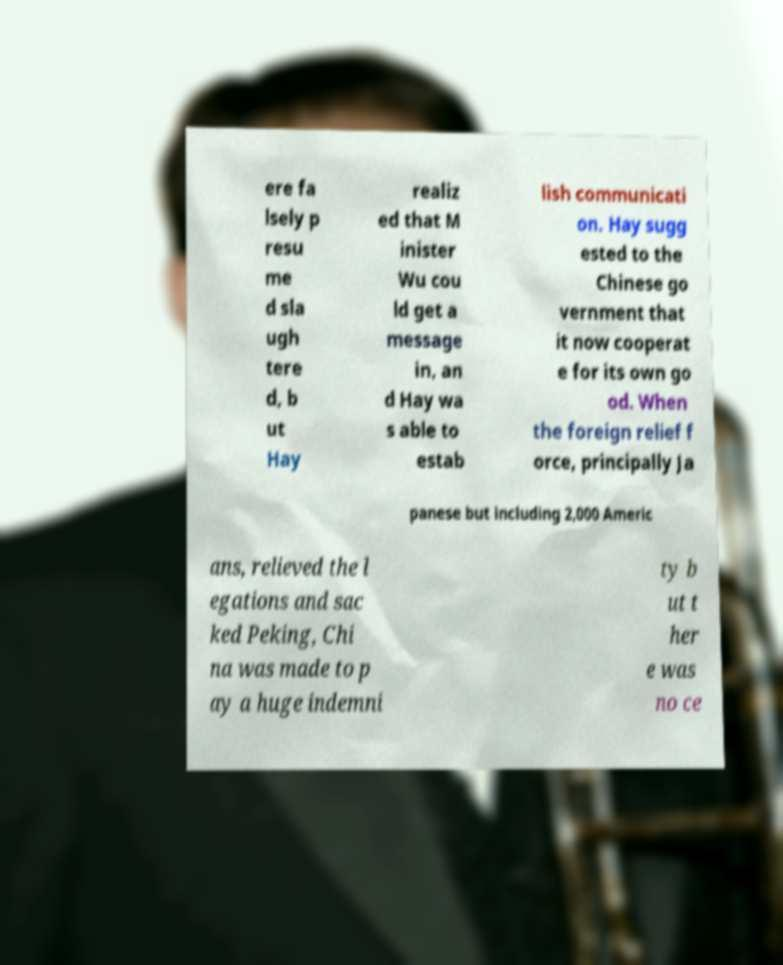I need the written content from this picture converted into text. Can you do that? ere fa lsely p resu me d sla ugh tere d, b ut Hay realiz ed that M inister Wu cou ld get a message in, an d Hay wa s able to estab lish communicati on. Hay sugg ested to the Chinese go vernment that it now cooperat e for its own go od. When the foreign relief f orce, principally Ja panese but including 2,000 Americ ans, relieved the l egations and sac ked Peking, Chi na was made to p ay a huge indemni ty b ut t her e was no ce 